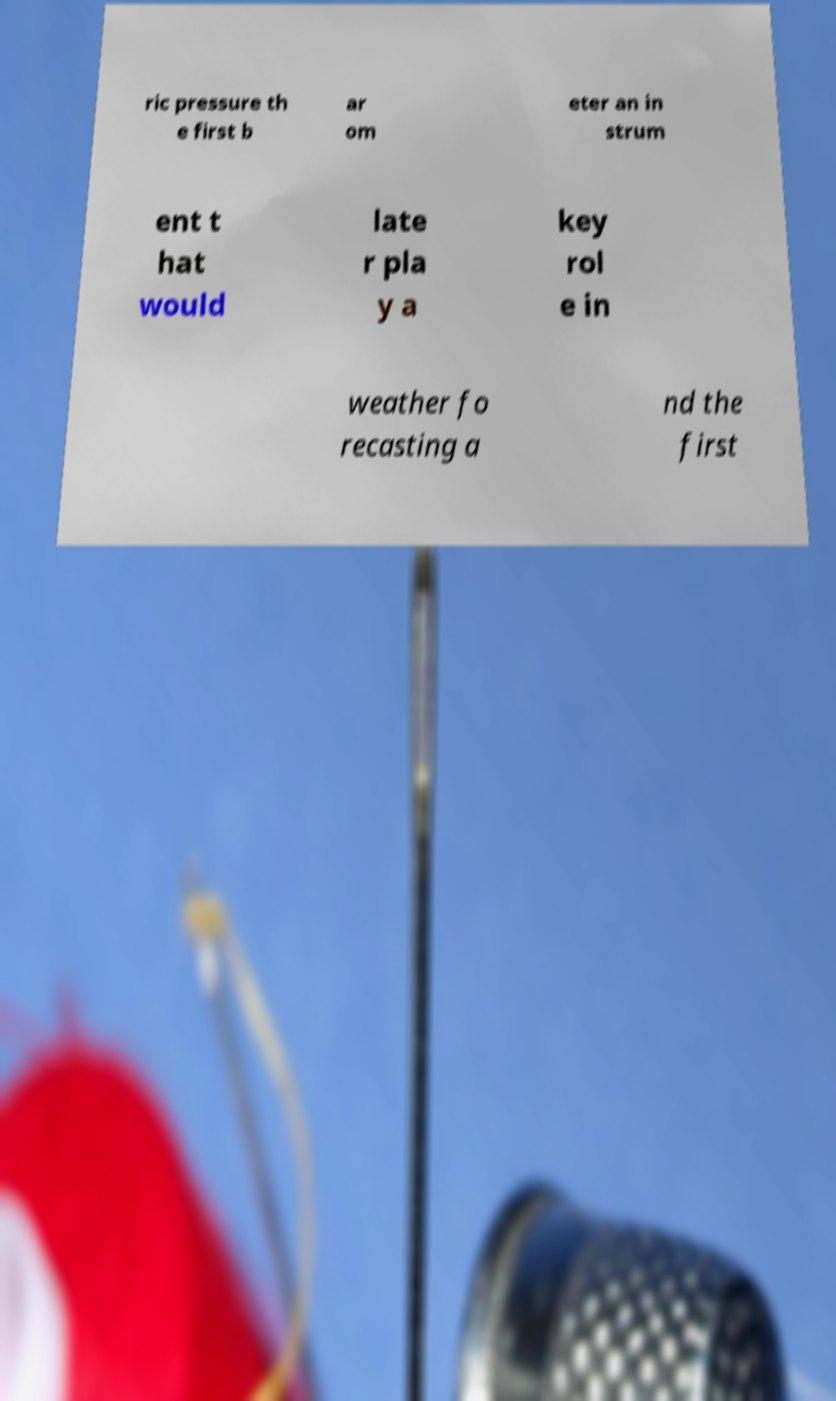Can you accurately transcribe the text from the provided image for me? ric pressure th e first b ar om eter an in strum ent t hat would late r pla y a key rol e in weather fo recasting a nd the first 